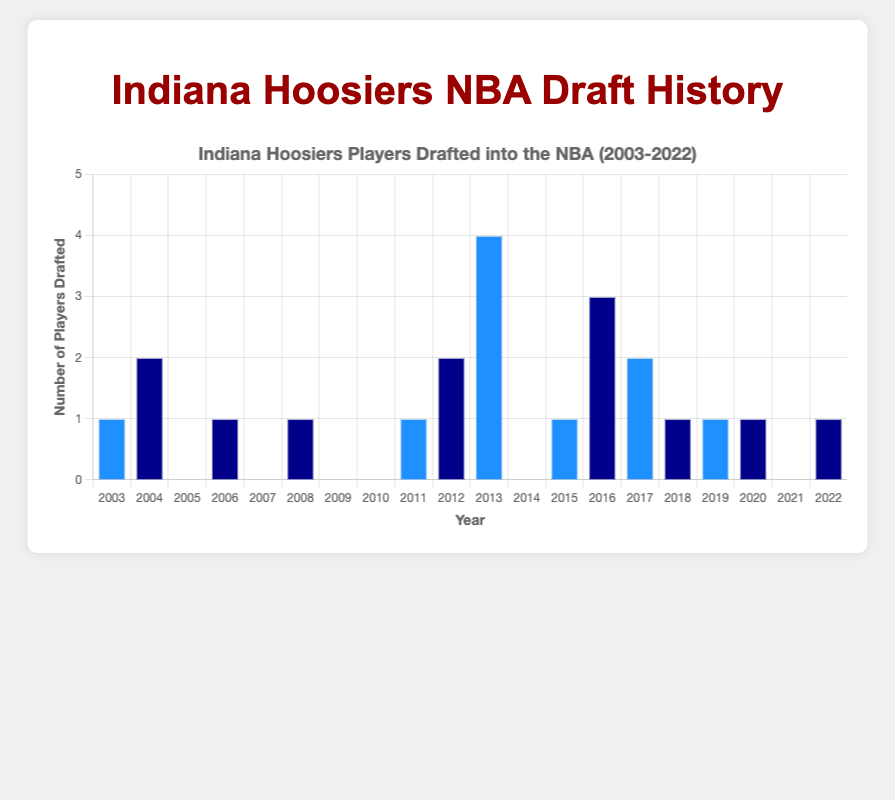What is the total number of Indiana Hoosiers players drafted into the NBA in the past 20 years? To find the total number, add up all the players drafted each year: 1+2+0+1+0+1+0+0+1+2+4+0+1+3+2+1+1+1+0+1.
Answer: 22 In which year were the most Indiana Hoosiers players drafted into the NBA, and how many were drafted? Observing the heights of the bars, the highest number of players drafted occurred in 2013 with 4 players.
Answer: 2013, 4 players Which years had no Indiana Hoosiers players drafted into the NBA? Look for years where the bar's height is zero. Those years are: 2005, 2007, 2009, 2010, 2014, and 2021.
Answer: 2005, 2007, 2009, 2010, 2014, 2021 What is the average number of Indiana Hoosiers players drafted per year over the past 20 years? Sum the total number of players drafted (22) and divide by the number of years (20). The average is 22/20.
Answer: 1.1 Compare the number of players drafted in 2013 to those drafted in 2012. Which year had more, and by how many? In 2012, there were 2 players drafted, and in 2013, there were 4. Subtract the number in 2012 from 2013 to get the difference: 4-2.
Answer: 2013, 2 more players Calculate the median number of players drafted per year over the past 20 years. List the numbers drafted each year in ascending order: 0, 0, 0, 0, 0, 1, 1, 1, 1, 1, 1, 1, 1, 1, 2, 2, 2, 3, 4. With 20 years, the median is the average of the 10th and 11th values: (1+1)/2.
Answer: 1 How many years had exactly one Indiana Hoosiers player drafted into the NBA? Count the bars with a height representing '1'. Those years are: 2003, 2006, 2008, 2011, 2015, 2018, 2019, 2020, 2022.
Answer: 9 What was the difference in the number of players drafted between 2004 and 2005? From the chart, 2 players were drafted in 2004, and 0 in 2005. The difference is 2-0.
Answer: 2 Which bar colors are associated with even and odd index years, respectively? According to the chart description, even-indexed years use blue and odd-indexed years use dark blue.
Answer: Blue for even, Dark blue for odd 